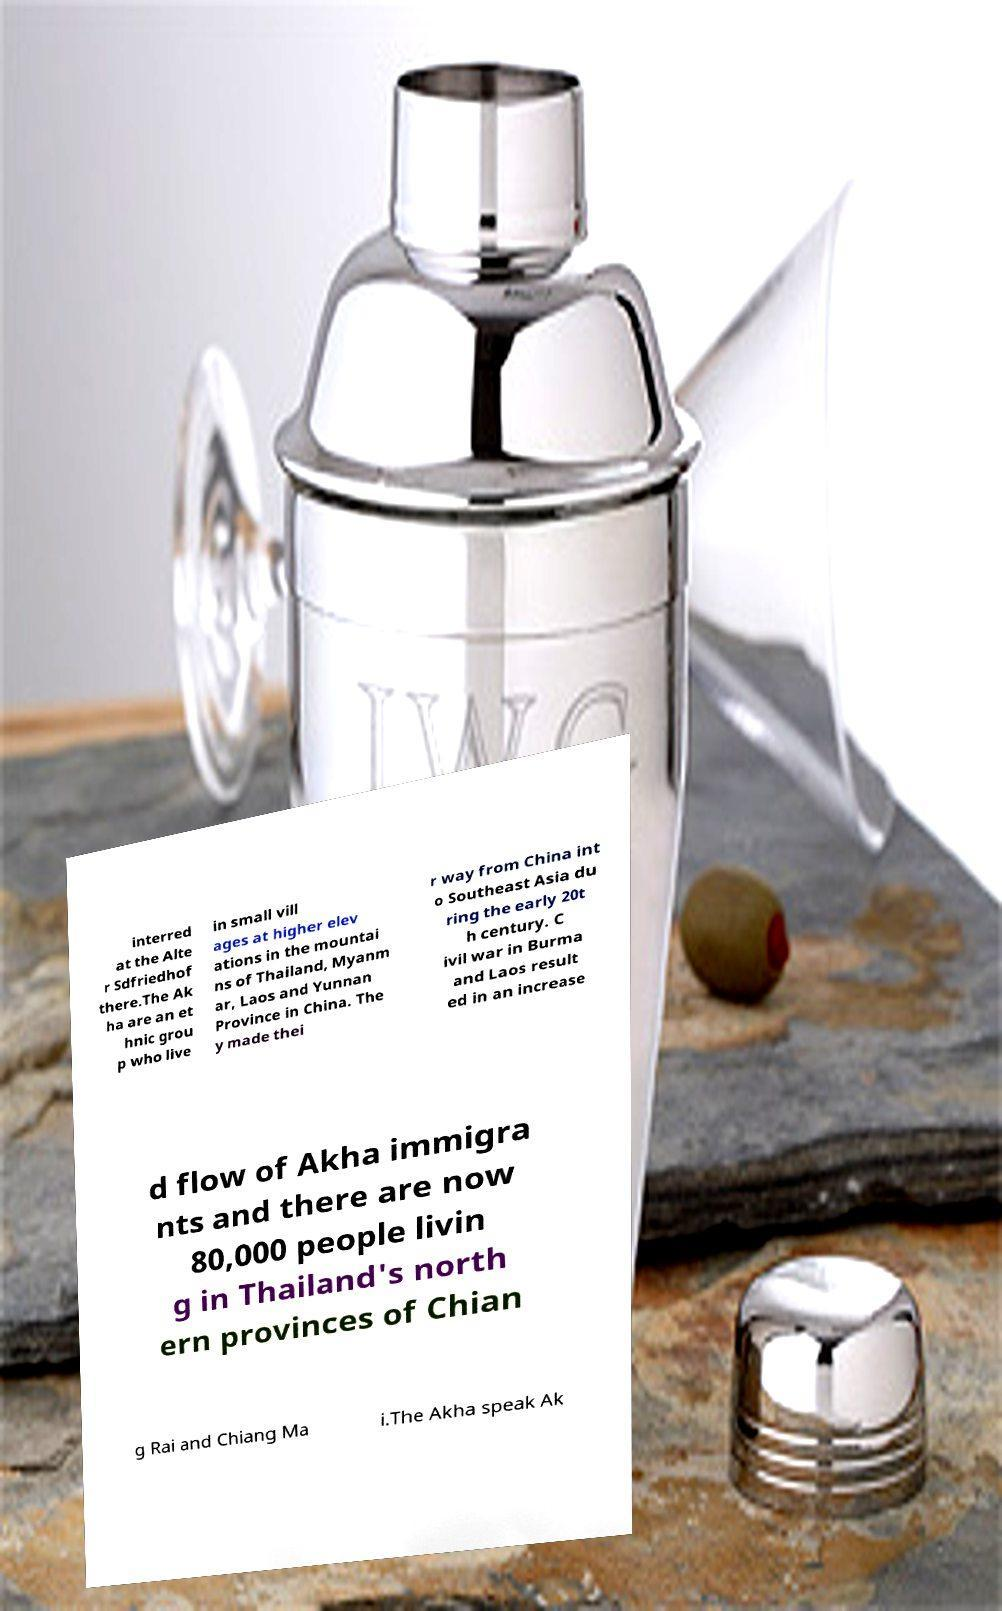Can you read and provide the text displayed in the image?This photo seems to have some interesting text. Can you extract and type it out for me? interred at the Alte r Sdfriedhof there.The Ak ha are an et hnic grou p who live in small vill ages at higher elev ations in the mountai ns of Thailand, Myanm ar, Laos and Yunnan Province in China. The y made thei r way from China int o Southeast Asia du ring the early 20t h century. C ivil war in Burma and Laos result ed in an increase d flow of Akha immigra nts and there are now 80,000 people livin g in Thailand's north ern provinces of Chian g Rai and Chiang Ma i.The Akha speak Ak 